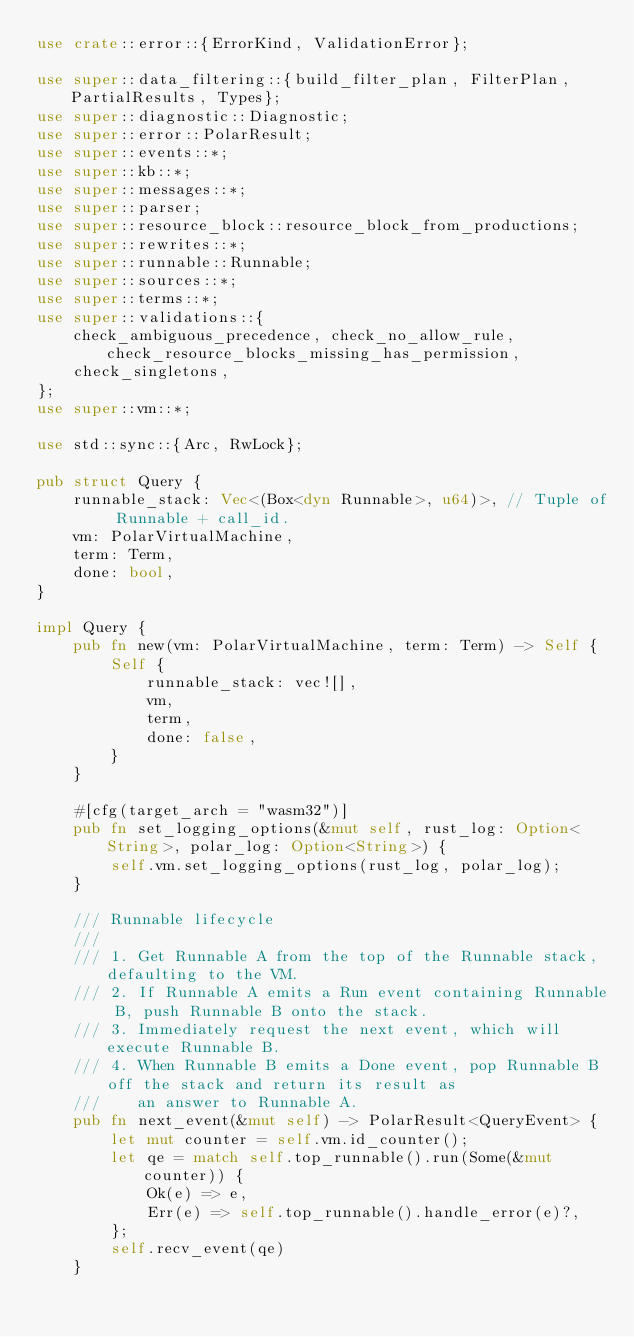Convert code to text. <code><loc_0><loc_0><loc_500><loc_500><_Rust_>use crate::error::{ErrorKind, ValidationError};

use super::data_filtering::{build_filter_plan, FilterPlan, PartialResults, Types};
use super::diagnostic::Diagnostic;
use super::error::PolarResult;
use super::events::*;
use super::kb::*;
use super::messages::*;
use super::parser;
use super::resource_block::resource_block_from_productions;
use super::rewrites::*;
use super::runnable::Runnable;
use super::sources::*;
use super::terms::*;
use super::validations::{
    check_ambiguous_precedence, check_no_allow_rule, check_resource_blocks_missing_has_permission,
    check_singletons,
};
use super::vm::*;

use std::sync::{Arc, RwLock};

pub struct Query {
    runnable_stack: Vec<(Box<dyn Runnable>, u64)>, // Tuple of Runnable + call_id.
    vm: PolarVirtualMachine,
    term: Term,
    done: bool,
}

impl Query {
    pub fn new(vm: PolarVirtualMachine, term: Term) -> Self {
        Self {
            runnable_stack: vec![],
            vm,
            term,
            done: false,
        }
    }

    #[cfg(target_arch = "wasm32")]
    pub fn set_logging_options(&mut self, rust_log: Option<String>, polar_log: Option<String>) {
        self.vm.set_logging_options(rust_log, polar_log);
    }

    /// Runnable lifecycle
    ///
    /// 1. Get Runnable A from the top of the Runnable stack, defaulting to the VM.
    /// 2. If Runnable A emits a Run event containing Runnable B, push Runnable B onto the stack.
    /// 3. Immediately request the next event, which will execute Runnable B.
    /// 4. When Runnable B emits a Done event, pop Runnable B off the stack and return its result as
    ///    an answer to Runnable A.
    pub fn next_event(&mut self) -> PolarResult<QueryEvent> {
        let mut counter = self.vm.id_counter();
        let qe = match self.top_runnable().run(Some(&mut counter)) {
            Ok(e) => e,
            Err(e) => self.top_runnable().handle_error(e)?,
        };
        self.recv_event(qe)
    }
</code> 